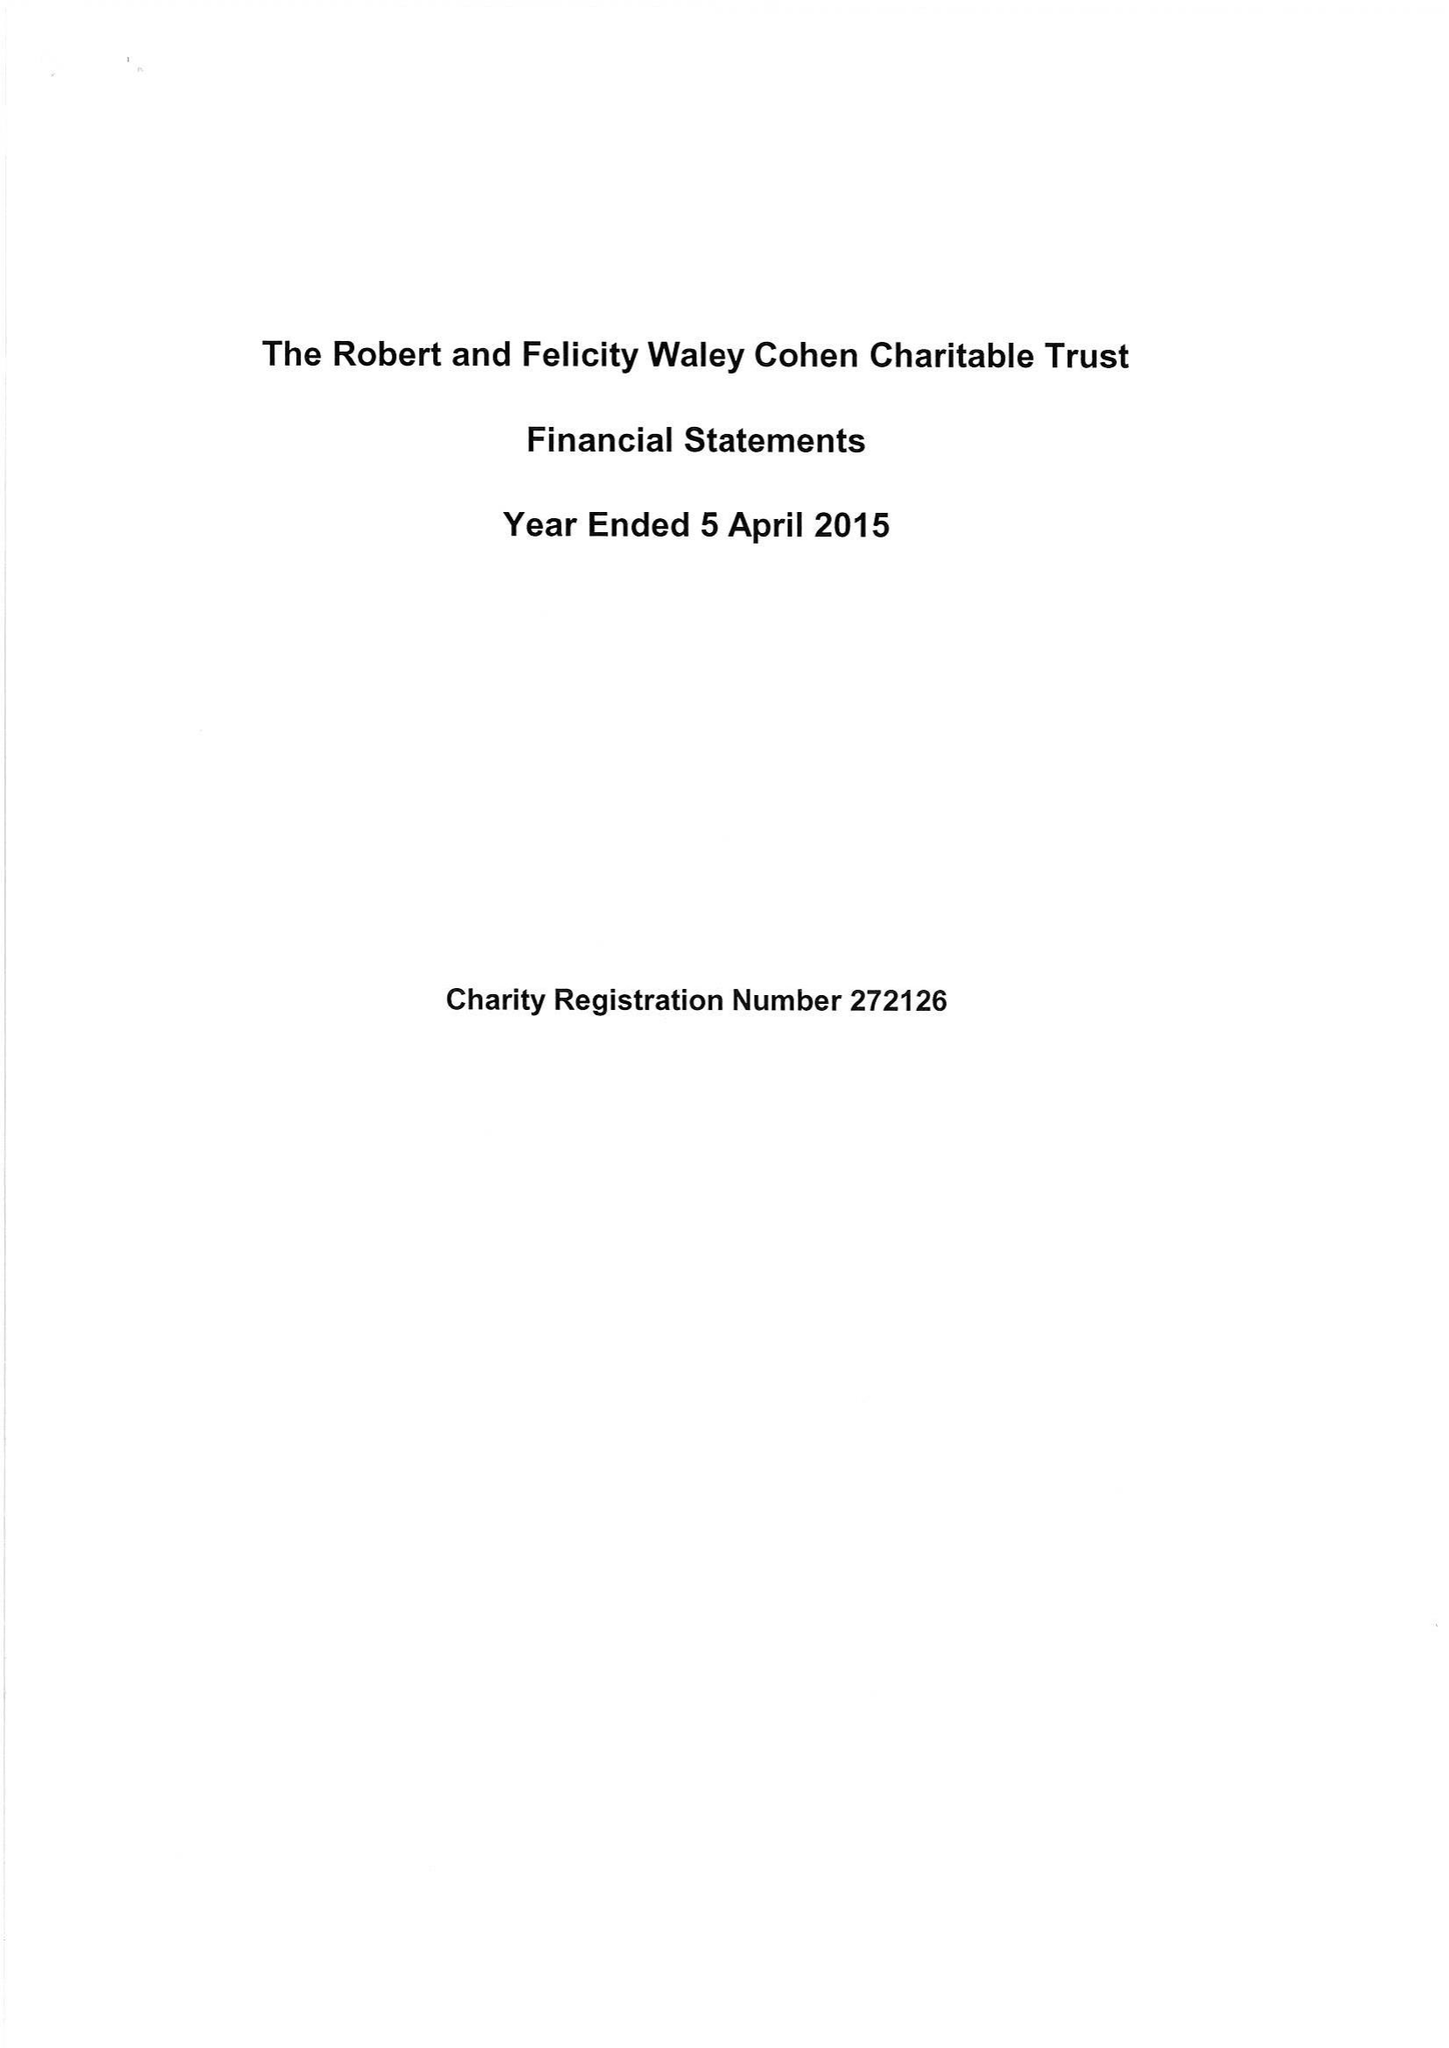What is the value for the address__street_line?
Answer the question using a single word or phrase. 27 SOUTH TERRACE 